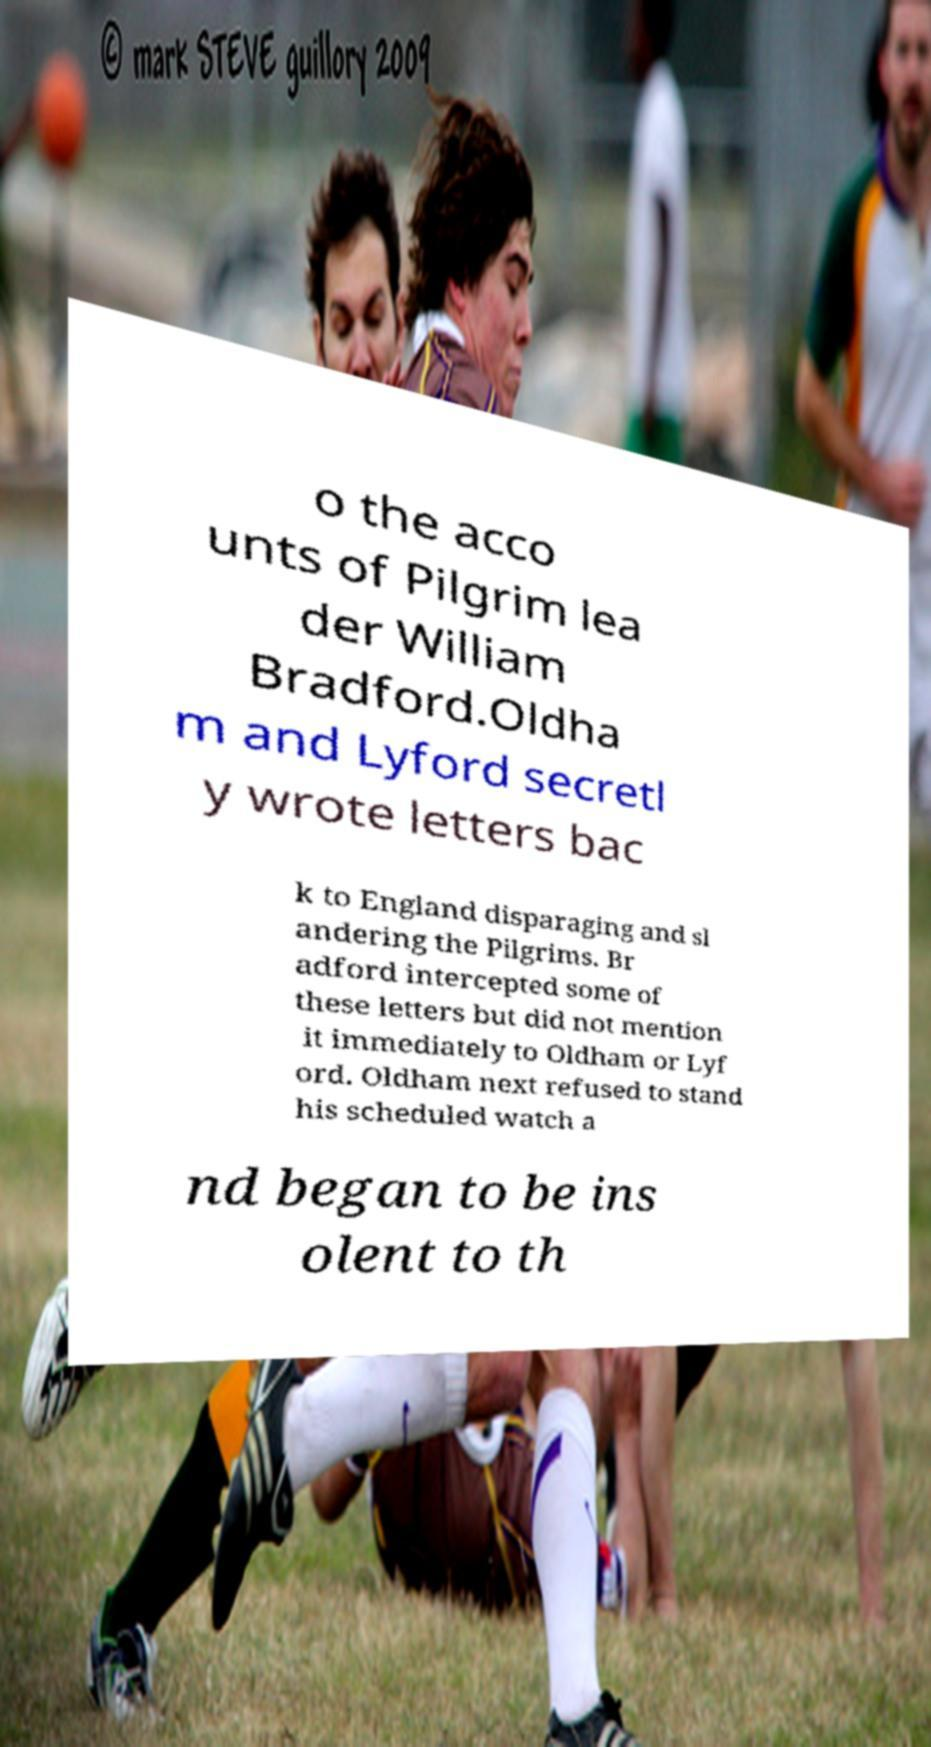Could you extract and type out the text from this image? o the acco unts of Pilgrim lea der William Bradford.Oldha m and Lyford secretl y wrote letters bac k to England disparaging and sl andering the Pilgrims. Br adford intercepted some of these letters but did not mention it immediately to Oldham or Lyf ord. Oldham next refused to stand his scheduled watch a nd began to be ins olent to th 